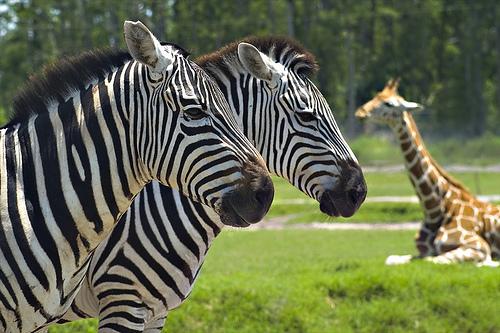Do these animals live in Africa?
Keep it brief. Yes. Are the zebras taller than the giraffes?
Be succinct. No. What animal is this?
Give a very brief answer. Zebra. What kind of animal is laying down?
Concise answer only. Giraffe. How many animals are in the image?
Write a very short answer. 3. Are any of the animals eating?
Quick response, please. No. 